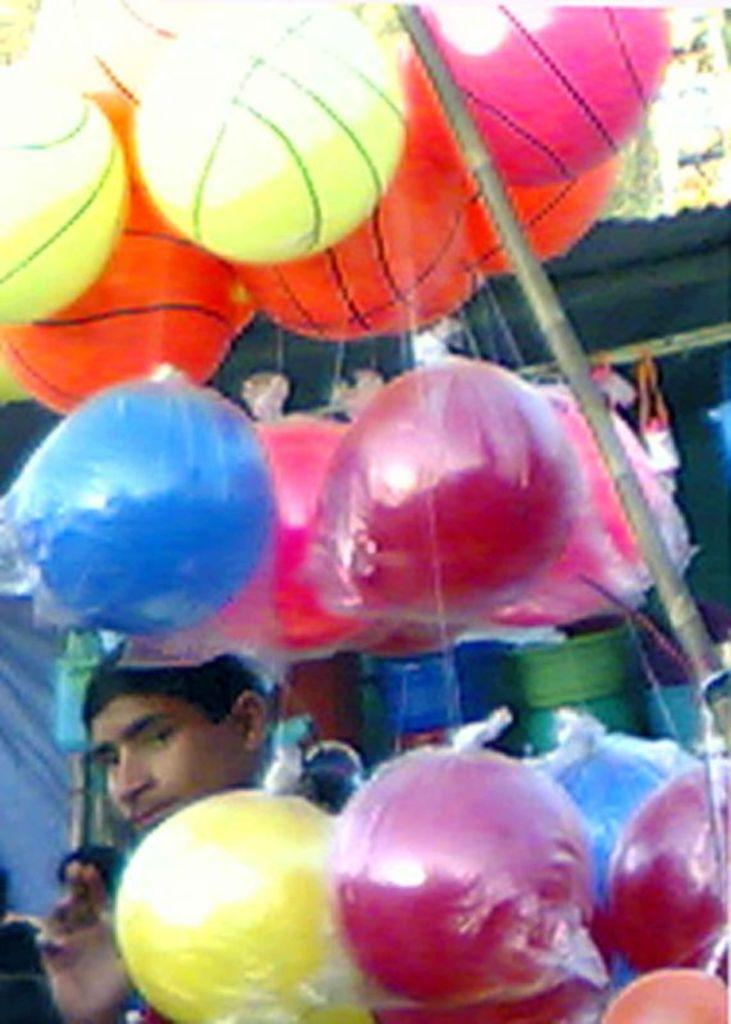What is the main subject of the image? There is a person in the image. What activity might the person be engaged in, based on the objects in the image? The person might be playing with the balls tied to a pole. What can be seen in the background of the image? There is a tent and plastic vessels visible in the background. How many thumbs does the person have in the image? The number of thumbs the person has cannot be determined from the image alone. 